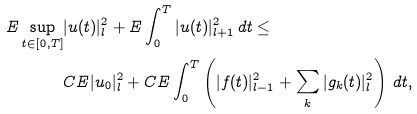<formula> <loc_0><loc_0><loc_500><loc_500>E \sup _ { t \in [ 0 , T ] } & | u ( t ) | ^ { 2 } _ { l } + E \int _ { 0 } ^ { T } | u ( t ) | ^ { 2 } _ { l + 1 } \, d t \leq \\ & C E | u _ { 0 } | ^ { 2 } _ { l } + C E \int _ { 0 } ^ { T } \left ( | f ( t ) | ^ { 2 } _ { l - 1 } + \sum _ { k } | g _ { k } ( t ) | ^ { 2 } _ { l } \right ) \, d t ,</formula> 